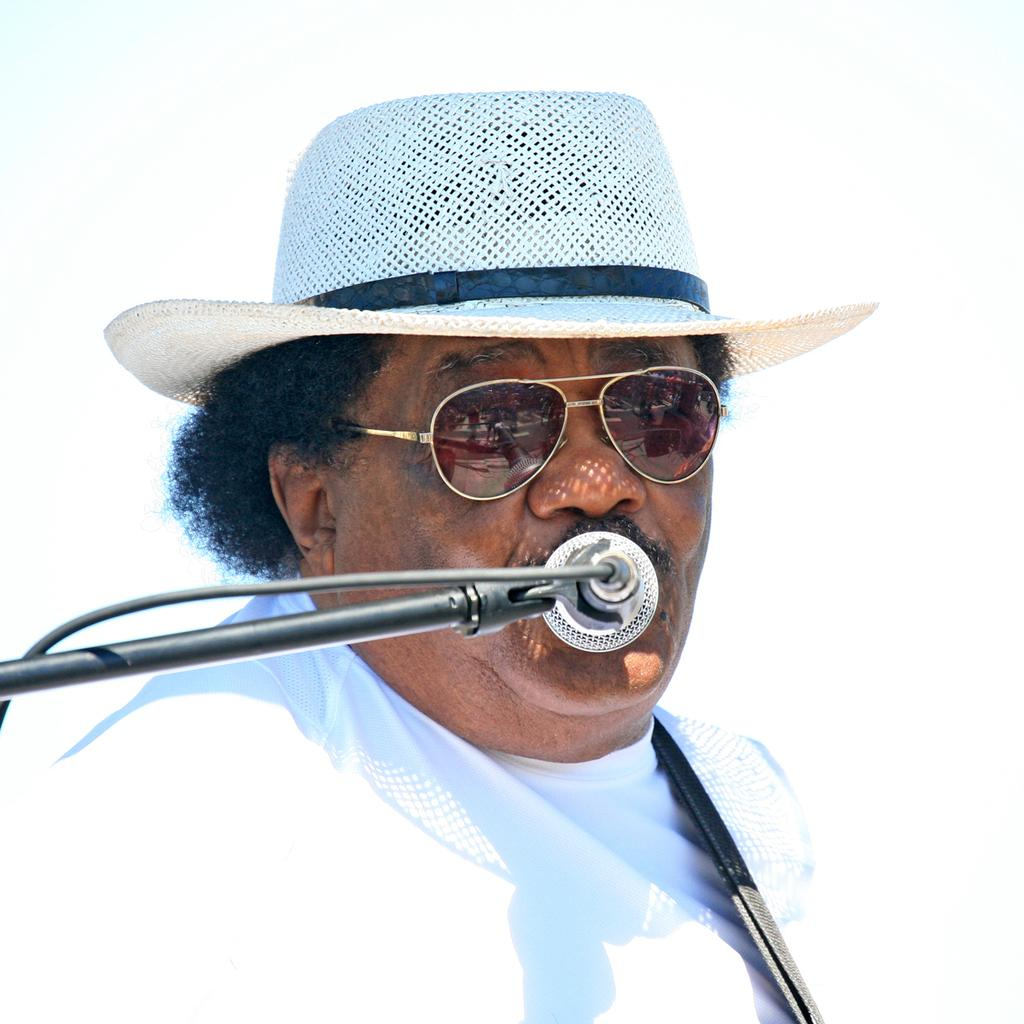Who is the main subject in the image? There is a person in the center of the image. What is the person wearing? The person is wearing a white dress, a hat, and spectacles. What object is located in the middle of the image? There is a mic in the middle of the image. What type of cheese is being served on the railway in the image? There is no cheese or railway present in the image. 